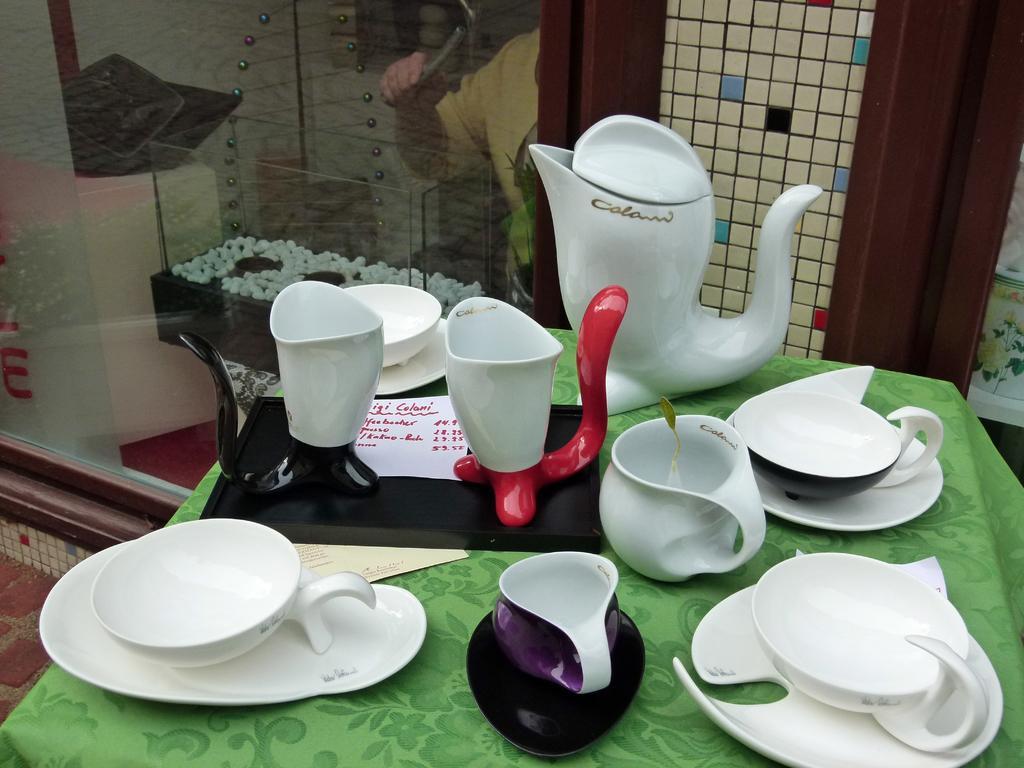How would you summarize this image in a sentence or two? This is a picture in a restaurant. In the foreground of the picture there is a table. On the table there are cups, saucers, teapot and a menu card. They are placed on a table. At the top there is a door and a glass window. 